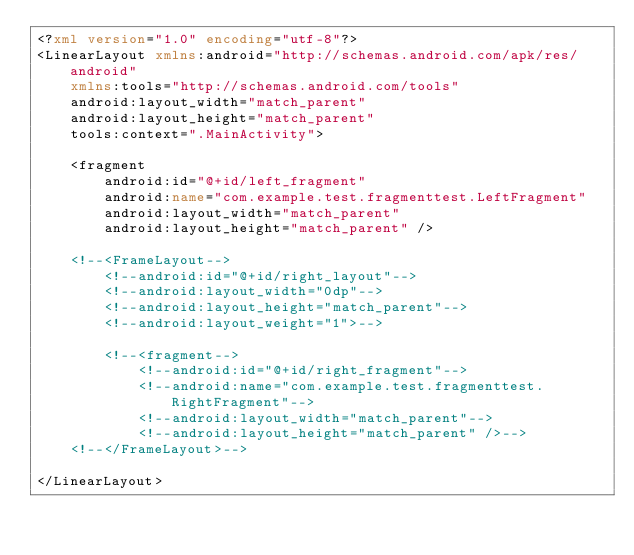Convert code to text. <code><loc_0><loc_0><loc_500><loc_500><_XML_><?xml version="1.0" encoding="utf-8"?>
<LinearLayout xmlns:android="http://schemas.android.com/apk/res/android"
    xmlns:tools="http://schemas.android.com/tools"
    android:layout_width="match_parent"
    android:layout_height="match_parent"
    tools:context=".MainActivity">

    <fragment
        android:id="@+id/left_fragment"
        android:name="com.example.test.fragmenttest.LeftFragment"
        android:layout_width="match_parent"
        android:layout_height="match_parent" />

    <!--<FrameLayout-->
        <!--android:id="@+id/right_layout"-->
        <!--android:layout_width="0dp"-->
        <!--android:layout_height="match_parent"-->
        <!--android:layout_weight="1">-->

        <!--<fragment-->
            <!--android:id="@+id/right_fragment"-->
            <!--android:name="com.example.test.fragmenttest.RightFragment"-->
            <!--android:layout_width="match_parent"-->
            <!--android:layout_height="match_parent" />-->
    <!--</FrameLayout>-->

</LinearLayout></code> 